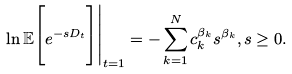<formula> <loc_0><loc_0><loc_500><loc_500>\ln \mathbb { E } \Big [ e ^ { - s D _ { t } } \Big ] \Big | _ { t = 1 } = - \sum _ { k = 1 } ^ { N } c _ { k } ^ { \beta _ { k } } s ^ { \beta _ { k } } , s \geq 0 .</formula> 